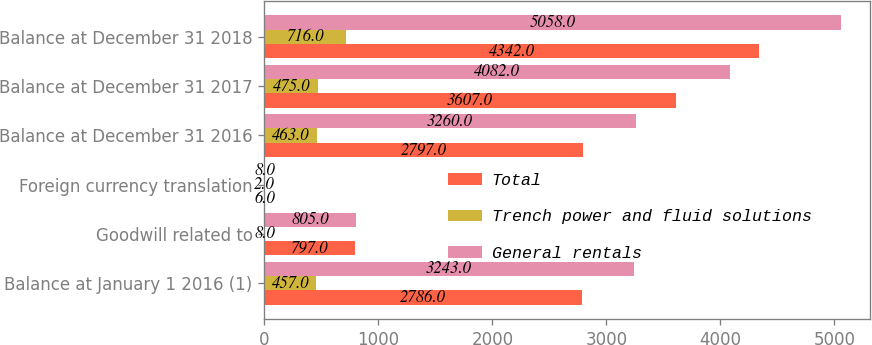Convert chart to OTSL. <chart><loc_0><loc_0><loc_500><loc_500><stacked_bar_chart><ecel><fcel>Balance at January 1 2016 (1)<fcel>Goodwill related to<fcel>Foreign currency translation<fcel>Balance at December 31 2016<fcel>Balance at December 31 2017<fcel>Balance at December 31 2018<nl><fcel>Total<fcel>2786<fcel>797<fcel>6<fcel>2797<fcel>3607<fcel>4342<nl><fcel>Trench power and fluid solutions<fcel>457<fcel>8<fcel>2<fcel>463<fcel>475<fcel>716<nl><fcel>General rentals<fcel>3243<fcel>805<fcel>8<fcel>3260<fcel>4082<fcel>5058<nl></chart> 